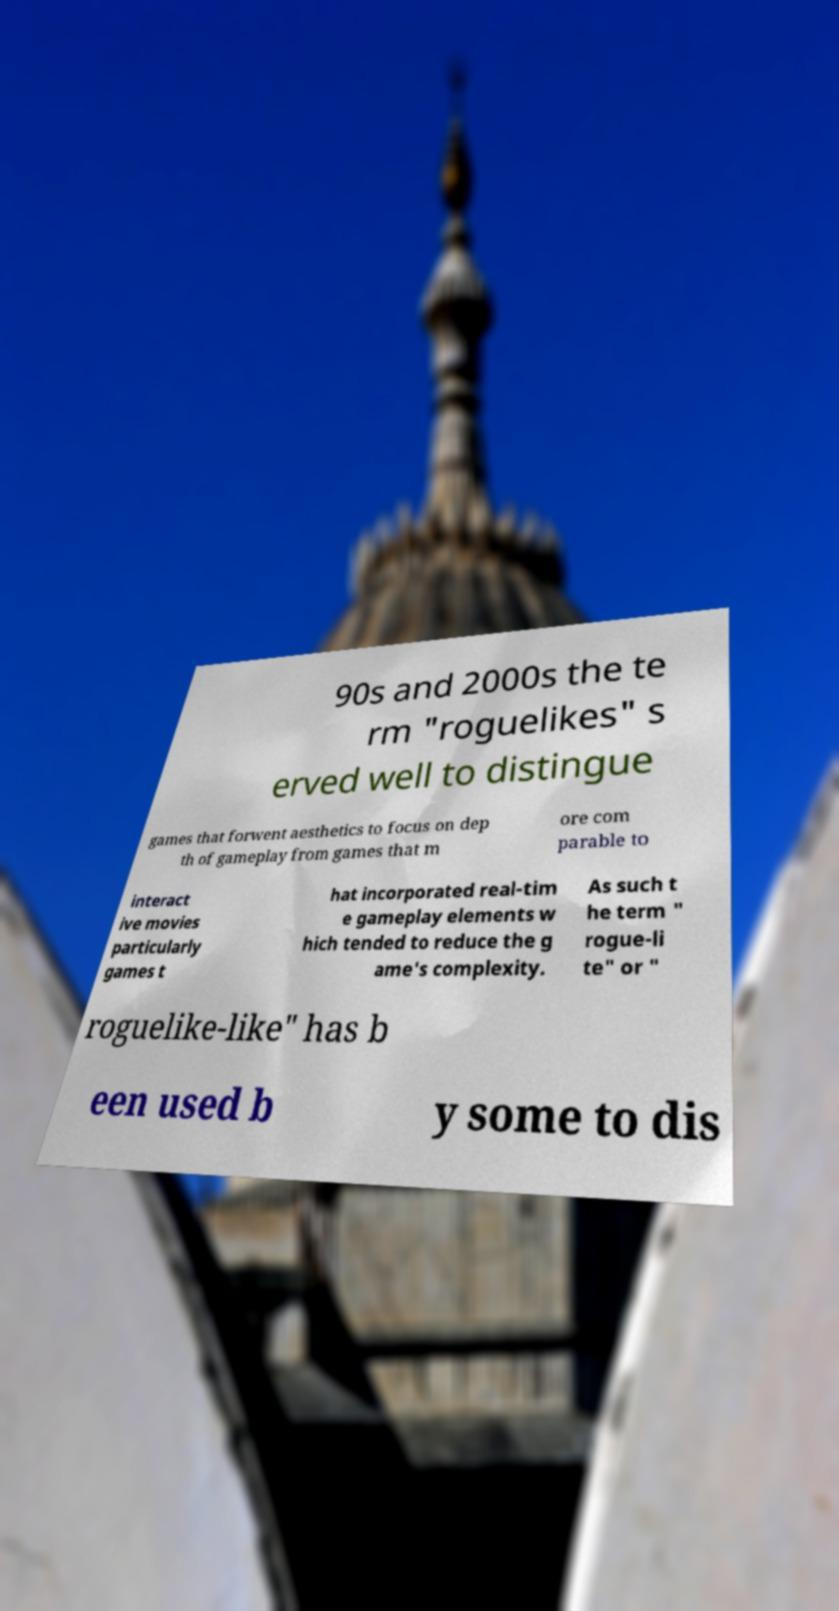What messages or text are displayed in this image? I need them in a readable, typed format. 90s and 2000s the te rm "roguelikes" s erved well to distingue games that forwent aesthetics to focus on dep th of gameplay from games that m ore com parable to interact ive movies particularly games t hat incorporated real-tim e gameplay elements w hich tended to reduce the g ame's complexity. As such t he term " rogue-li te" or " roguelike-like" has b een used b y some to dis 